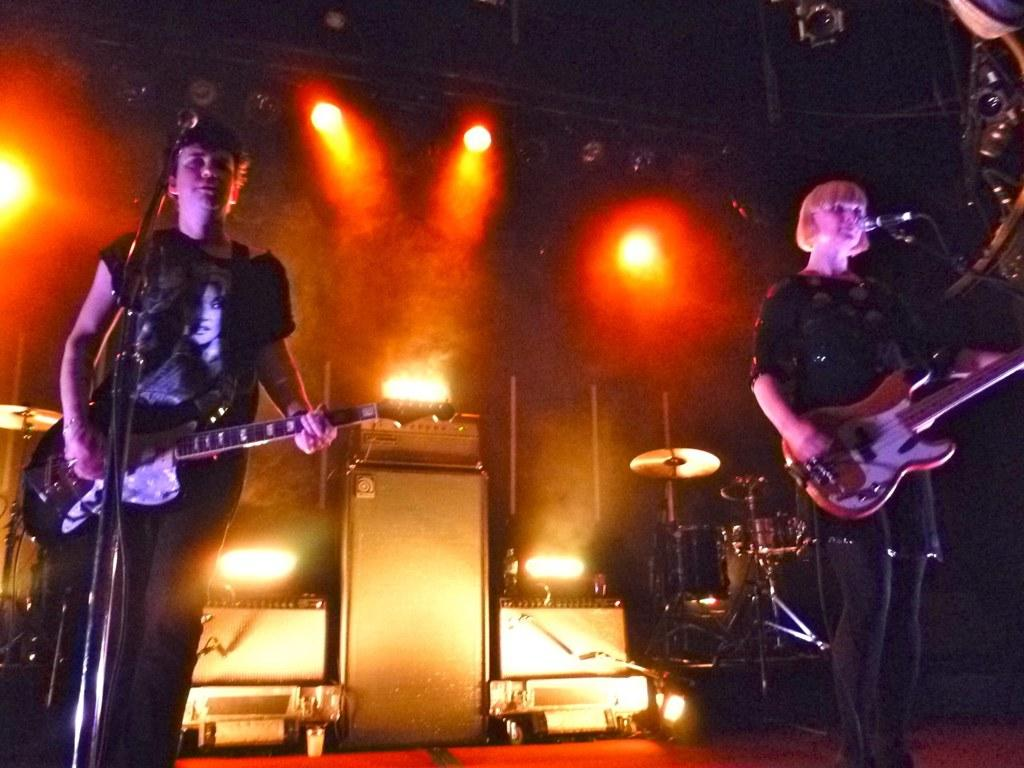How many people are present in the image? There is a man and a woman in the image. What are the man and the woman holding in the image? Both the man and the woman are holding guitars. What can be seen in the background of the image? There are lights, speakers, and a drum set in the background of the image. What does the man need to do in order to call his brother at night? There is no information about the man needing to call his brother or the time of day in the image. 